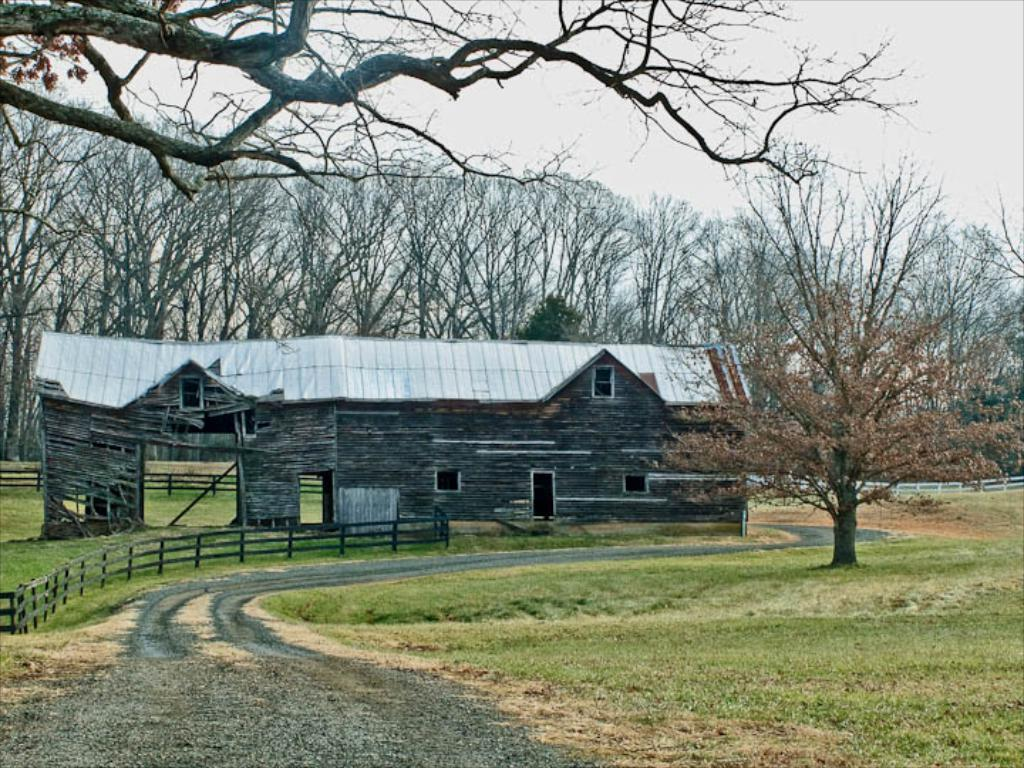What type of structure is visible in the image? There is a building with windows in the image. What is present near the building? There is fencing in the image. What is the ground covered with in the image? There is grass on the ground in the image. What can be seen in the distance in the image? There are trees in the background of the image. What is visible above the building and trees in the image? The sky is visible in the image. How many jellyfish are swimming in the grass in the image? There are no jellyfish present in the image; the ground is covered with grass. 